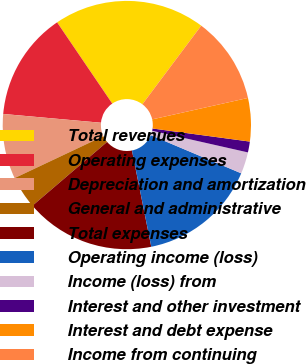Convert chart. <chart><loc_0><loc_0><loc_500><loc_500><pie_chart><fcel>Total revenues<fcel>Operating expenses<fcel>Depreciation and amortization<fcel>General and administrative<fcel>Total expenses<fcel>Operating income (loss)<fcel>Income (loss) from<fcel>Interest and other investment<fcel>Interest and debt expense<fcel>Income from continuing<nl><fcel>19.72%<fcel>14.08%<fcel>8.45%<fcel>4.23%<fcel>16.9%<fcel>15.49%<fcel>2.82%<fcel>1.41%<fcel>5.63%<fcel>11.27%<nl></chart> 